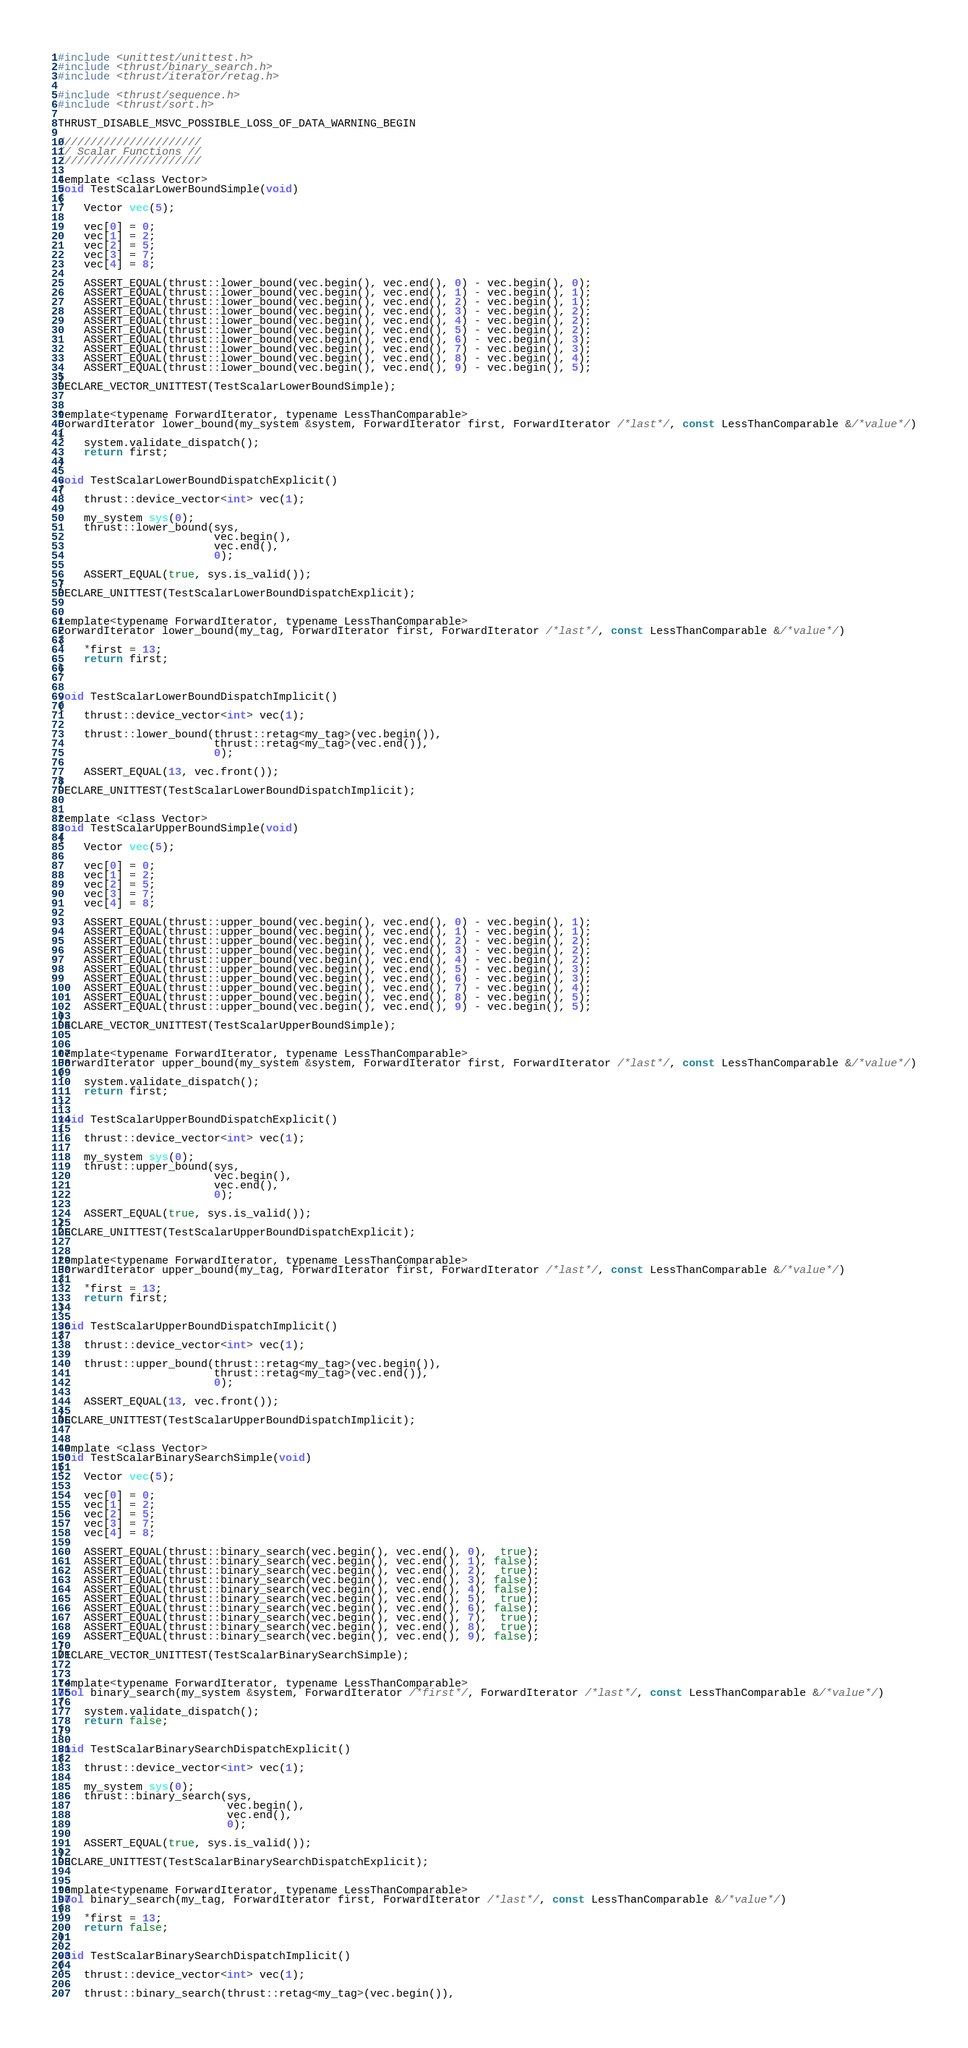<code> <loc_0><loc_0><loc_500><loc_500><_Cuda_>#include <unittest/unittest.h>
#include <thrust/binary_search.h>
#include <thrust/iterator/retag.h>

#include <thrust/sequence.h>
#include <thrust/sort.h>

THRUST_DISABLE_MSVC_POSSIBLE_LOSS_OF_DATA_WARNING_BEGIN

//////////////////////
// Scalar Functions //
//////////////////////

template <class Vector>
void TestScalarLowerBoundSimple(void)
{
    Vector vec(5);

    vec[0] = 0;
    vec[1] = 2;
    vec[2] = 5;
    vec[3] = 7;
    vec[4] = 8;

    ASSERT_EQUAL(thrust::lower_bound(vec.begin(), vec.end(), 0) - vec.begin(), 0);
    ASSERT_EQUAL(thrust::lower_bound(vec.begin(), vec.end(), 1) - vec.begin(), 1);
    ASSERT_EQUAL(thrust::lower_bound(vec.begin(), vec.end(), 2) - vec.begin(), 1);
    ASSERT_EQUAL(thrust::lower_bound(vec.begin(), vec.end(), 3) - vec.begin(), 2);
    ASSERT_EQUAL(thrust::lower_bound(vec.begin(), vec.end(), 4) - vec.begin(), 2);
    ASSERT_EQUAL(thrust::lower_bound(vec.begin(), vec.end(), 5) - vec.begin(), 2);
    ASSERT_EQUAL(thrust::lower_bound(vec.begin(), vec.end(), 6) - vec.begin(), 3);
    ASSERT_EQUAL(thrust::lower_bound(vec.begin(), vec.end(), 7) - vec.begin(), 3);
    ASSERT_EQUAL(thrust::lower_bound(vec.begin(), vec.end(), 8) - vec.begin(), 4);
    ASSERT_EQUAL(thrust::lower_bound(vec.begin(), vec.end(), 9) - vec.begin(), 5);
}
DECLARE_VECTOR_UNITTEST(TestScalarLowerBoundSimple);


template<typename ForwardIterator, typename LessThanComparable>
ForwardIterator lower_bound(my_system &system, ForwardIterator first, ForwardIterator /*last*/, const LessThanComparable &/*value*/)
{
    system.validate_dispatch();
    return first;
}

void TestScalarLowerBoundDispatchExplicit()
{
    thrust::device_vector<int> vec(1);

    my_system sys(0);
    thrust::lower_bound(sys,
                        vec.begin(),
                        vec.end(),
                        0);

    ASSERT_EQUAL(true, sys.is_valid());
}
DECLARE_UNITTEST(TestScalarLowerBoundDispatchExplicit);


template<typename ForwardIterator, typename LessThanComparable>
ForwardIterator lower_bound(my_tag, ForwardIterator first, ForwardIterator /*last*/, const LessThanComparable &/*value*/)
{
    *first = 13;
    return first;
}


void TestScalarLowerBoundDispatchImplicit()
{
    thrust::device_vector<int> vec(1);

    thrust::lower_bound(thrust::retag<my_tag>(vec.begin()),
                        thrust::retag<my_tag>(vec.end()),
                        0);

    ASSERT_EQUAL(13, vec.front());
}
DECLARE_UNITTEST(TestScalarLowerBoundDispatchImplicit);


template <class Vector>
void TestScalarUpperBoundSimple(void)
{
    Vector vec(5);

    vec[0] = 0;
    vec[1] = 2;
    vec[2] = 5;
    vec[3] = 7;
    vec[4] = 8;

    ASSERT_EQUAL(thrust::upper_bound(vec.begin(), vec.end(), 0) - vec.begin(), 1);
    ASSERT_EQUAL(thrust::upper_bound(vec.begin(), vec.end(), 1) - vec.begin(), 1);
    ASSERT_EQUAL(thrust::upper_bound(vec.begin(), vec.end(), 2) - vec.begin(), 2);
    ASSERT_EQUAL(thrust::upper_bound(vec.begin(), vec.end(), 3) - vec.begin(), 2);
    ASSERT_EQUAL(thrust::upper_bound(vec.begin(), vec.end(), 4) - vec.begin(), 2);
    ASSERT_EQUAL(thrust::upper_bound(vec.begin(), vec.end(), 5) - vec.begin(), 3);
    ASSERT_EQUAL(thrust::upper_bound(vec.begin(), vec.end(), 6) - vec.begin(), 3);
    ASSERT_EQUAL(thrust::upper_bound(vec.begin(), vec.end(), 7) - vec.begin(), 4);
    ASSERT_EQUAL(thrust::upper_bound(vec.begin(), vec.end(), 8) - vec.begin(), 5);
    ASSERT_EQUAL(thrust::upper_bound(vec.begin(), vec.end(), 9) - vec.begin(), 5);
}
DECLARE_VECTOR_UNITTEST(TestScalarUpperBoundSimple);


template<typename ForwardIterator, typename LessThanComparable>
ForwardIterator upper_bound(my_system &system, ForwardIterator first, ForwardIterator /*last*/, const LessThanComparable &/*value*/)
{
    system.validate_dispatch();
    return first;
}

void TestScalarUpperBoundDispatchExplicit()
{
    thrust::device_vector<int> vec(1);

    my_system sys(0);
    thrust::upper_bound(sys,
                        vec.begin(),
                        vec.end(),
                        0);

    ASSERT_EQUAL(true, sys.is_valid());
}
DECLARE_UNITTEST(TestScalarUpperBoundDispatchExplicit);


template<typename ForwardIterator, typename LessThanComparable>
ForwardIterator upper_bound(my_tag, ForwardIterator first, ForwardIterator /*last*/, const LessThanComparable &/*value*/)
{
    *first = 13;
    return first;
}

void TestScalarUpperBoundDispatchImplicit()
{
    thrust::device_vector<int> vec(1);

    thrust::upper_bound(thrust::retag<my_tag>(vec.begin()),
                        thrust::retag<my_tag>(vec.end()),
                        0);

    ASSERT_EQUAL(13, vec.front());
}
DECLARE_UNITTEST(TestScalarUpperBoundDispatchImplicit);


template <class Vector>
void TestScalarBinarySearchSimple(void)
{
    Vector vec(5);

    vec[0] = 0;
    vec[1] = 2;
    vec[2] = 5;
    vec[3] = 7;
    vec[4] = 8;

    ASSERT_EQUAL(thrust::binary_search(vec.begin(), vec.end(), 0),  true);
    ASSERT_EQUAL(thrust::binary_search(vec.begin(), vec.end(), 1), false);
    ASSERT_EQUAL(thrust::binary_search(vec.begin(), vec.end(), 2),  true);
    ASSERT_EQUAL(thrust::binary_search(vec.begin(), vec.end(), 3), false);
    ASSERT_EQUAL(thrust::binary_search(vec.begin(), vec.end(), 4), false);
    ASSERT_EQUAL(thrust::binary_search(vec.begin(), vec.end(), 5),  true);
    ASSERT_EQUAL(thrust::binary_search(vec.begin(), vec.end(), 6), false);
    ASSERT_EQUAL(thrust::binary_search(vec.begin(), vec.end(), 7),  true);
    ASSERT_EQUAL(thrust::binary_search(vec.begin(), vec.end(), 8),  true);
    ASSERT_EQUAL(thrust::binary_search(vec.begin(), vec.end(), 9), false);
}
DECLARE_VECTOR_UNITTEST(TestScalarBinarySearchSimple);


template<typename ForwardIterator, typename LessThanComparable>
bool binary_search(my_system &system, ForwardIterator /*first*/, ForwardIterator /*last*/, const LessThanComparable &/*value*/)
{
    system.validate_dispatch();
    return false;
}

void TestScalarBinarySearchDispatchExplicit()
{
    thrust::device_vector<int> vec(1);

    my_system sys(0);
    thrust::binary_search(sys,
                          vec.begin(),
                          vec.end(),
                          0);

    ASSERT_EQUAL(true, sys.is_valid());
}
DECLARE_UNITTEST(TestScalarBinarySearchDispatchExplicit);


template<typename ForwardIterator, typename LessThanComparable>
bool binary_search(my_tag, ForwardIterator first, ForwardIterator /*last*/, const LessThanComparable &/*value*/)
{
    *first = 13;
    return false;
}

void TestScalarBinarySearchDispatchImplicit()
{
    thrust::device_vector<int> vec(1);

    thrust::binary_search(thrust::retag<my_tag>(vec.begin()),</code> 